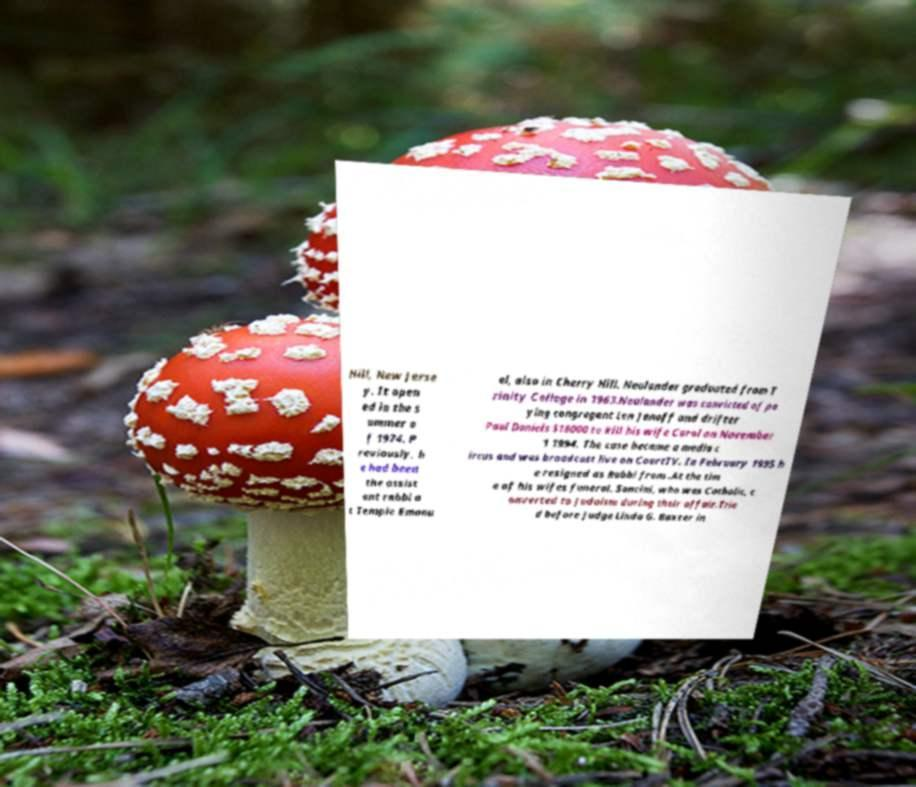Please read and relay the text visible in this image. What does it say? Hill, New Jerse y. It open ed in the s ummer o f 1974. P reviously, h e had been the assist ant rabbi a t Temple Emanu el, also in Cherry Hill. Neulander graduated from T rinity College in 1963.Neulander was convicted of pa ying congregant Len Jenoff and drifter Paul Daniels $18000 to kill his wife Carol on November 1 1994. The case became a media c ircus and was broadcast live on CourtTV. In February 1995 h e resigned as Rabbi from .At the tim e of his wifes funeral. Soncini, who was Catholic, c onverted to Judaism during their affair.Trie d before Judge Linda G. Baxter in 